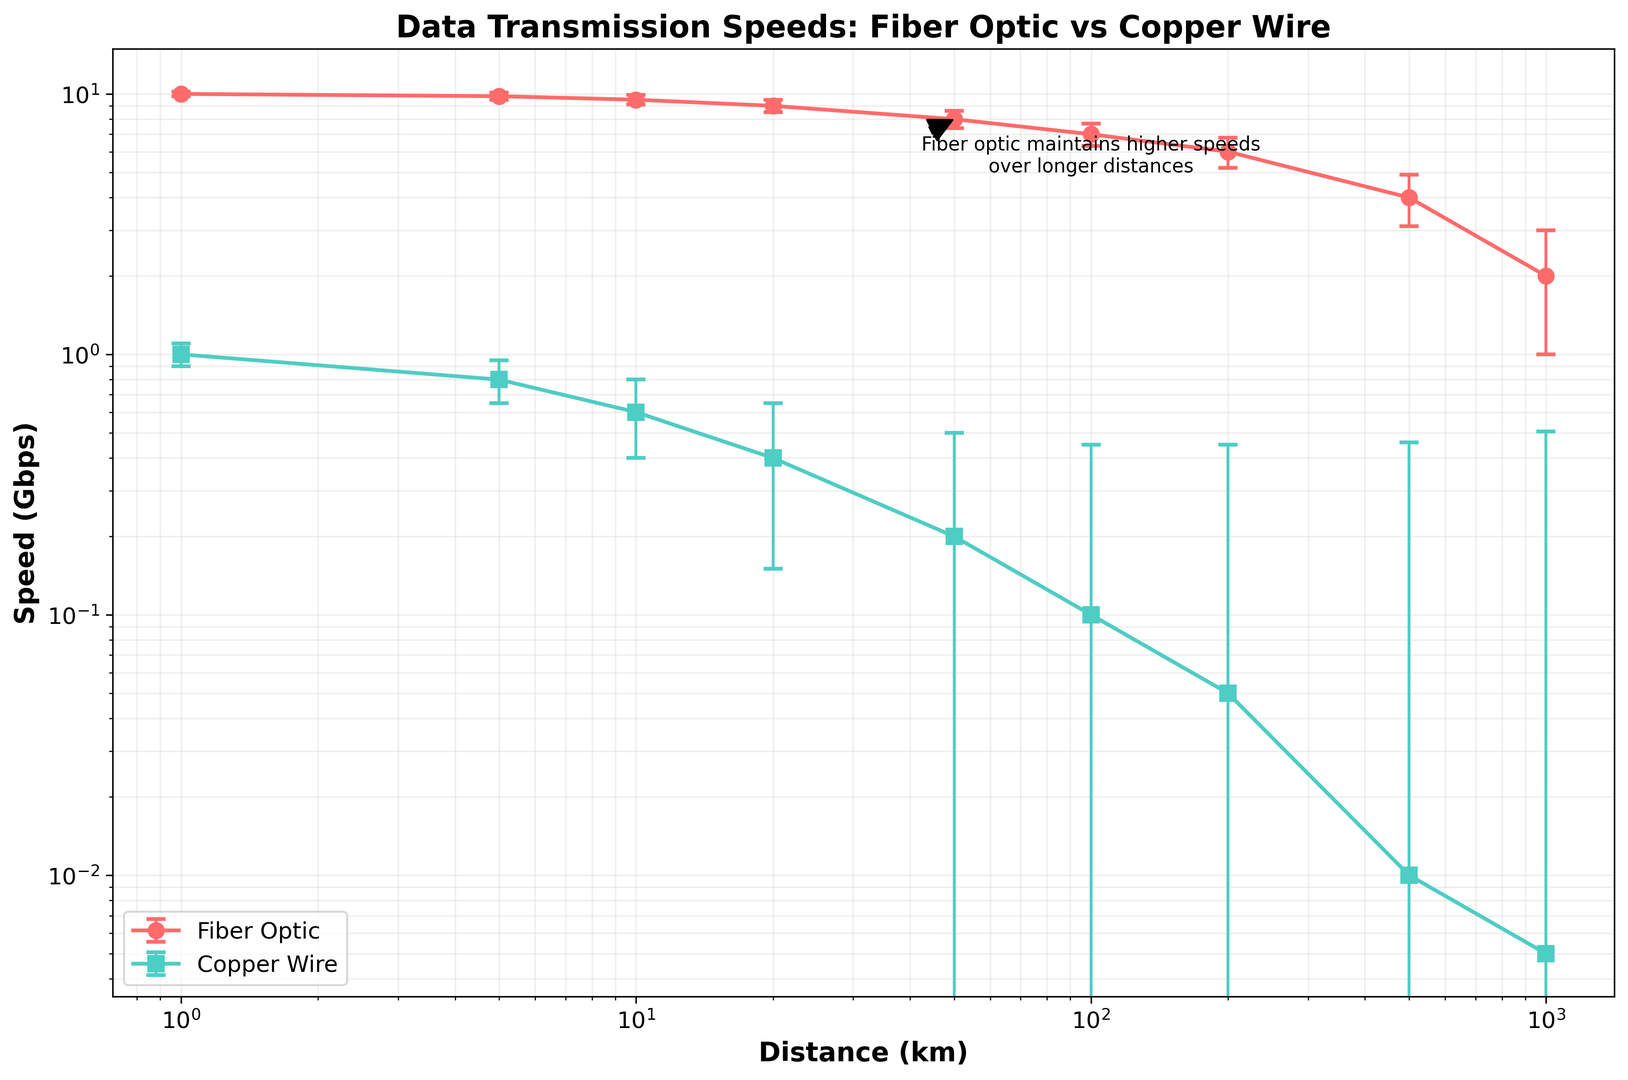What are the data transmission speeds for fiber optic and copper wire at a distance of 100 km? For a distance of 100 km, locate the corresponding points for both the fiber optic and copper wire on the graph. The fiber optic speed is around 7 Gbps, whereas the copper wire speed is around 0.1 Gbps.
Answer: Fiber Optic: 7 Gbps, Copper Wire: 0.1 Gbps How does the error margin compare between fiber optic and copper wire at 200 km? Find the error bars for both fiber optic and copper wire at 200 km. The error for fiber optic is about 0.8 Gbps, while for copper wire it is about 0.4 Gbps.
Answer: Fiber Optic: 0.8 Gbps, Copper Wire: 0.4 Gbps At what distance does the data transmission speed for copper wire fall below 0.1 Gbps? Look at the distances where copper wire speed decreases. The speed falls below 0.1 Gbps just after 100 km.
Answer: Just after 100 km Which material shows higher data transmission speed at a distance of 500 km, and by how much? Locate the data points for both materials at 500 km. Fiber optic shows a speed of 4 Gbps, while copper wire shows 0.01 Gbps. The difference in speed is 4 Gbps - 0.01 Gbps = 3.99 Gbps.
Answer: Fiber Optic by 3.99 Gbps What is the general trend of data transmission speeds for both materials as the distance increases? Observe the general pattern of the lines on the graph. As the distance increases, the data transmission speed decreases for both materials. However, fiber optic maintains higher speeds over longer distances compared to copper wire.
Answer: Both decrease, Fiber Optic maintains higher speeds How does the speed of fiber optic cables change from 1 km to 10 km? Find the speeds of fiber optic at 1 km and 10 km (10 Gbps and 9.5 Gbps). The change is 10 Gbps - 9.5 Gbps = 0.5 Gbps.
Answer: Decreases by 0.5 Gbps By what distance does the data transmission speed for fiber optic cables drop below 5 Gbps? Locate the point on the fiber optic graph where the speed falls below 5 Gbps. This occurs just between 200 km and 500 km.
Answer: Between 200 km and 500 km Which material has greater variability in data transmission speeds over 1000 km? Evaluate the length of the error bars over 1000 km. Fiber optic has an error margin of 1.0 Gbps, while copper wire has an error margin of 0.5 Gbps. Thus, fiber optic shows greater variability.
Answer: Fiber Optic 